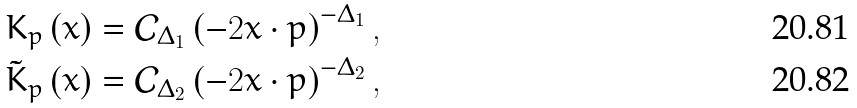Convert formula to latex. <formula><loc_0><loc_0><loc_500><loc_500>K _ { p } \left ( x \right ) & = \mathcal { C } _ { \Delta _ { 1 } } \left ( - 2 x \cdot p \right ) ^ { - \Delta _ { 1 } } , \\ \tilde { K } _ { p } \left ( x \right ) & = \mathcal { C } _ { \Delta _ { 2 } } \left ( - 2 x \cdot p \right ) ^ { - \Delta _ { 2 } } ,</formula> 